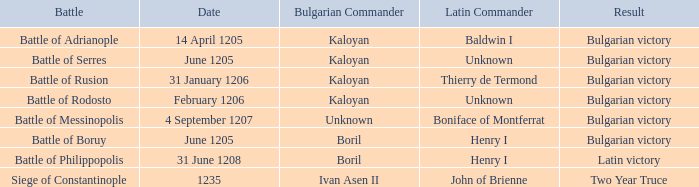What is the Result of the battle with Latin Commander Boniface of Montferrat? Bulgarian victory. 